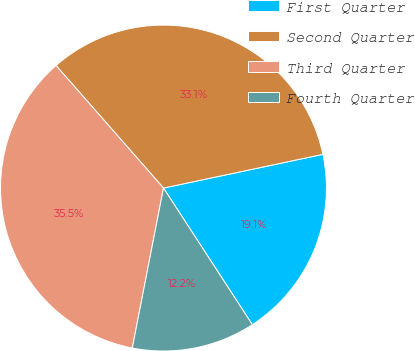Convert chart. <chart><loc_0><loc_0><loc_500><loc_500><pie_chart><fcel>First Quarter<fcel>Second Quarter<fcel>Third Quarter<fcel>Fourth Quarter<nl><fcel>19.14%<fcel>33.14%<fcel>35.48%<fcel>12.24%<nl></chart> 